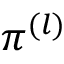<formula> <loc_0><loc_0><loc_500><loc_500>\pi ^ { ( l ) }</formula> 